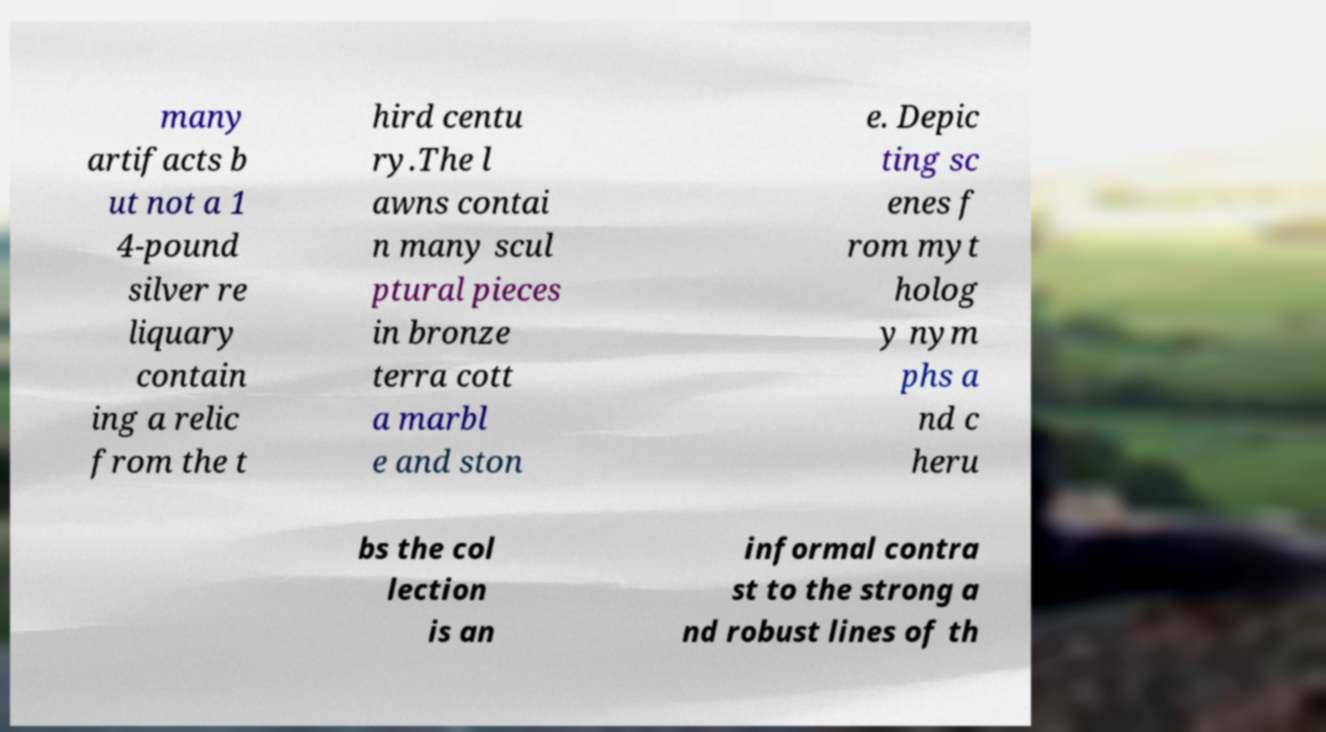For documentation purposes, I need the text within this image transcribed. Could you provide that? many artifacts b ut not a 1 4-pound silver re liquary contain ing a relic from the t hird centu ry.The l awns contai n many scul ptural pieces in bronze terra cott a marbl e and ston e. Depic ting sc enes f rom myt holog y nym phs a nd c heru bs the col lection is an informal contra st to the strong a nd robust lines of th 